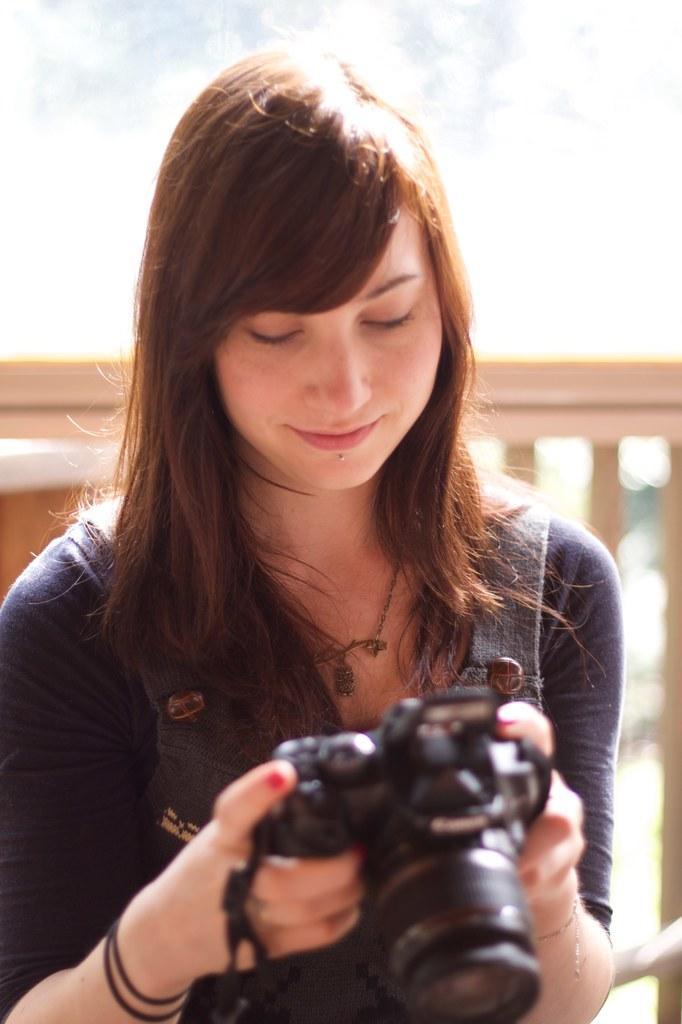Describe this image in one or two sentences. In this image, there is a lady standing and holding a camera on the bridge. In the background top of the image, there is a sky is visible which is white in color. This image is taken during a sunny time. 